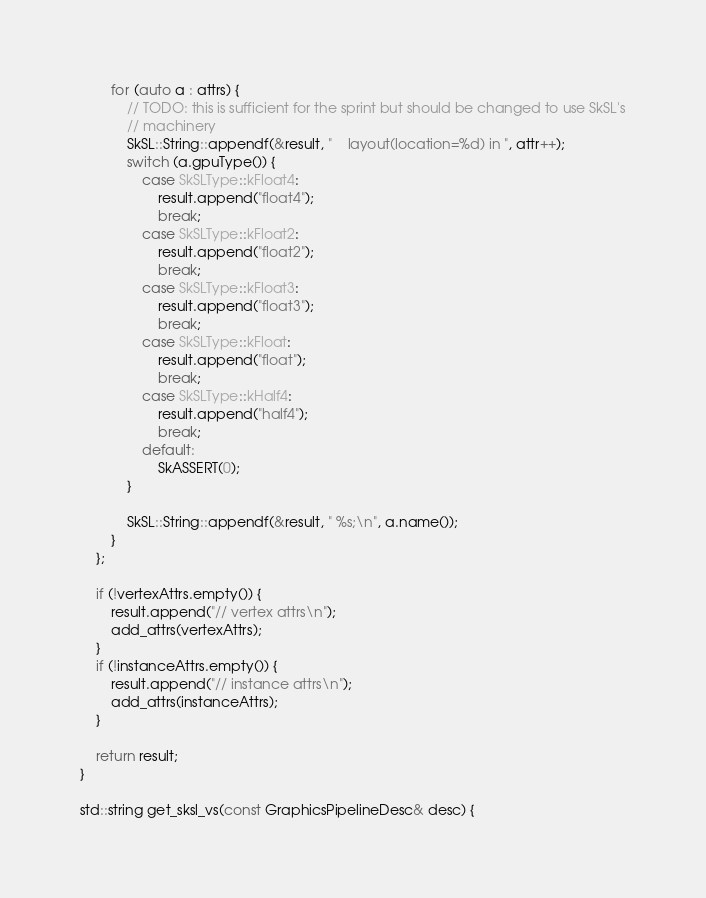Convert code to text. <code><loc_0><loc_0><loc_500><loc_500><_ObjectiveC_>        for (auto a : attrs) {
            // TODO: this is sufficient for the sprint but should be changed to use SkSL's
            // machinery
            SkSL::String::appendf(&result, "    layout(location=%d) in ", attr++);
            switch (a.gpuType()) {
                case SkSLType::kFloat4:
                    result.append("float4");
                    break;
                case SkSLType::kFloat2:
                    result.append("float2");
                    break;
                case SkSLType::kFloat3:
                    result.append("float3");
                    break;
                case SkSLType::kFloat:
                    result.append("float");
                    break;
                case SkSLType::kHalf4:
                    result.append("half4");
                    break;
                default:
                    SkASSERT(0);
            }

            SkSL::String::appendf(&result, " %s;\n", a.name());
        }
    };

    if (!vertexAttrs.empty()) {
        result.append("// vertex attrs\n");
        add_attrs(vertexAttrs);
    }
    if (!instanceAttrs.empty()) {
        result.append("// instance attrs\n");
        add_attrs(instanceAttrs);
    }

    return result;
}

std::string get_sksl_vs(const GraphicsPipelineDesc& desc) {</code> 